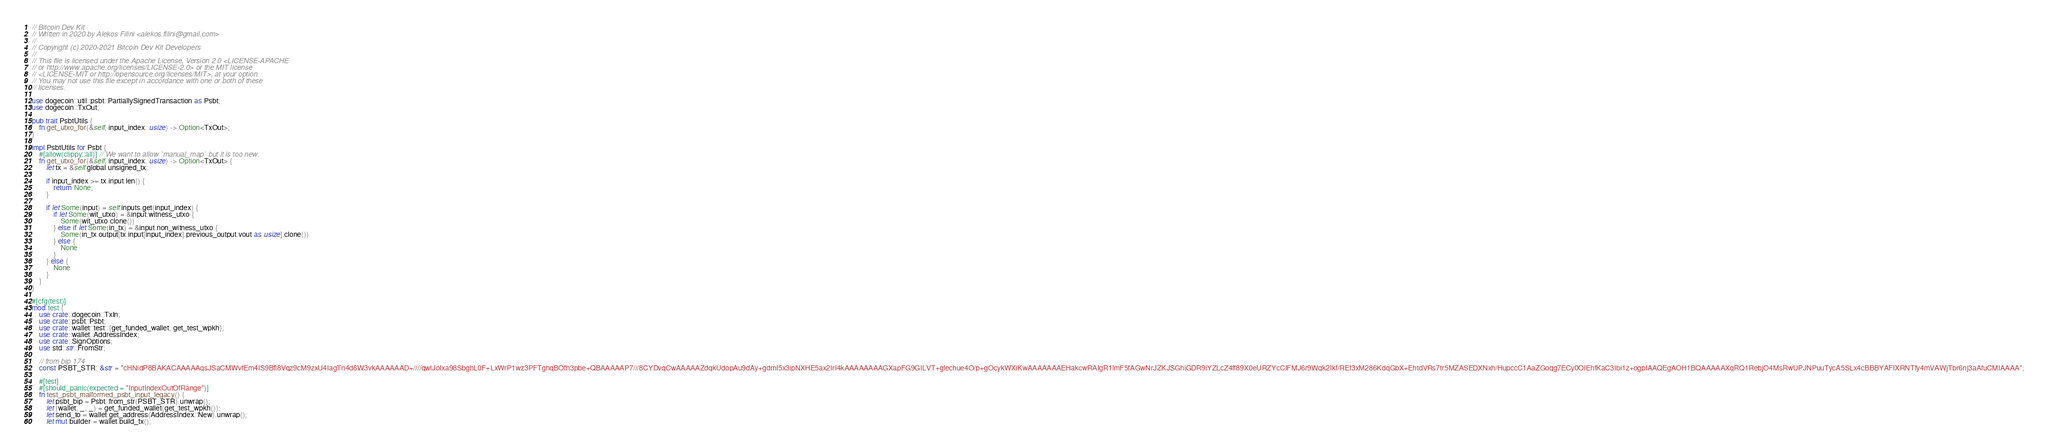<code> <loc_0><loc_0><loc_500><loc_500><_Rust_>// Bitcoin Dev Kit
// Written in 2020 by Alekos Filini <alekos.filini@gmail.com>
//
// Copyright (c) 2020-2021 Bitcoin Dev Kit Developers
//
// This file is licensed under the Apache License, Version 2.0 <LICENSE-APACHE
// or http://www.apache.org/licenses/LICENSE-2.0> or the MIT license
// <LICENSE-MIT or http://opensource.org/licenses/MIT>, at your option.
// You may not use this file except in accordance with one or both of these
// licenses.

use dogecoin::util::psbt::PartiallySignedTransaction as Psbt;
use dogecoin::TxOut;

pub trait PsbtUtils {
    fn get_utxo_for(&self, input_index: usize) -> Option<TxOut>;
}

impl PsbtUtils for Psbt {
    #[allow(clippy::all)] // We want to allow `manual_map` but it is too new.
    fn get_utxo_for(&self, input_index: usize) -> Option<TxOut> {
        let tx = &self.global.unsigned_tx;

        if input_index >= tx.input.len() {
            return None;
        }

        if let Some(input) = self.inputs.get(input_index) {
            if let Some(wit_utxo) = &input.witness_utxo {
                Some(wit_utxo.clone())
            } else if let Some(in_tx) = &input.non_witness_utxo {
                Some(in_tx.output[tx.input[input_index].previous_output.vout as usize].clone())
            } else {
                None
            }
        } else {
            None
        }
    }
}

#[cfg(test)]
mod test {
    use crate::dogecoin::TxIn;
    use crate::psbt::Psbt;
    use crate::wallet::test::{get_funded_wallet, get_test_wpkh};
    use crate::wallet::AddressIndex;
    use crate::SignOptions;
    use std::str::FromStr;

    // from bip 174
    const PSBT_STR: &str = "cHNidP8BAKACAAAAAqsJSaCMWvfEm4IS9Bfi8Vqz9cM9zxU4IagTn4d6W3vkAAAAAAD+////qwlJoIxa98SbghL0F+LxWrP1wz3PFTghqBOfh3pbe+QBAAAAAP7///8CYDvqCwAAAAAZdqkUdopAu9dAy+gdmI5x3ipNXHE5ax2IrI4kAAAAAAAAGXapFG9GILVT+glechue4O/p+gOcykWXiKwAAAAAAAEHakcwRAIgR1lmF5fAGwNrJZKJSGhiGDR9iYZLcZ4ff89X0eURZYcCIFMJ6r9Wqk2Ikf/REf3xM286KdqGbX+EhtdVRs7tr5MZASEDXNxh/HupccC1AaZGoqg7ECy0OIEhfKaC3Ibi1z+ogpIAAQEgAOH1BQAAAAAXqRQ1RebjO4MsRwUPJNPuuTycA5SLx4cBBBYAFIXRNTfy4mVAWjTbr6nj3aAfuCMIAAAA";

    #[test]
    #[should_panic(expected = "InputIndexOutOfRange")]
    fn test_psbt_malformed_psbt_input_legacy() {
        let psbt_bip = Psbt::from_str(PSBT_STR).unwrap();
        let (wallet, _, _) = get_funded_wallet(get_test_wpkh());
        let send_to = wallet.get_address(AddressIndex::New).unwrap();
        let mut builder = wallet.build_tx();</code> 